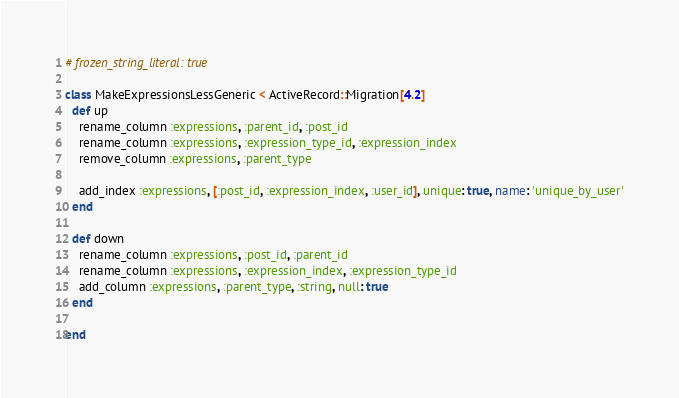Convert code to text. <code><loc_0><loc_0><loc_500><loc_500><_Ruby_># frozen_string_literal: true

class MakeExpressionsLessGeneric < ActiveRecord::Migration[4.2]
  def up
    rename_column :expressions, :parent_id, :post_id
    rename_column :expressions, :expression_type_id, :expression_index
    remove_column :expressions, :parent_type

    add_index :expressions, [:post_id, :expression_index, :user_id], unique: true, name: 'unique_by_user'
  end

  def down
    rename_column :expressions, :post_id, :parent_id
    rename_column :expressions, :expression_index, :expression_type_id
    add_column :expressions, :parent_type, :string, null: true
  end

end
</code> 